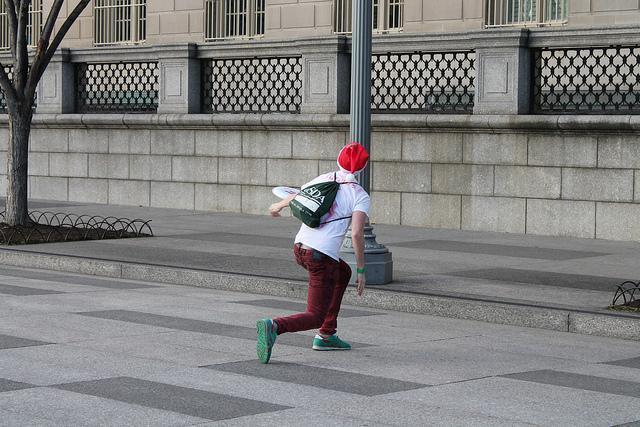What is the man doing?
Choose the correct response, then elucidate: 'Answer: answer
Rationale: rationale.'
Options: Sleeping, drinking, working out, running. Answer: running.
Rationale: The way his feet are apart he looks to be going fast to get somewhere. 